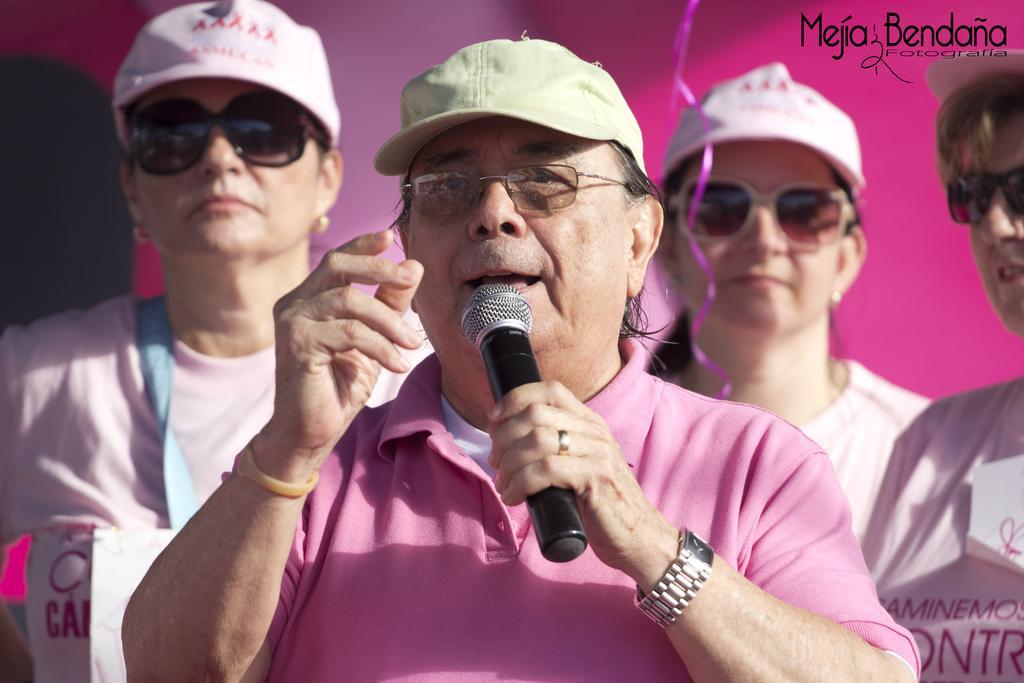Can you describe this image briefly? In this image i can see a group of people who are wearing hats and glasses. The person in the front is holding a microphone. 